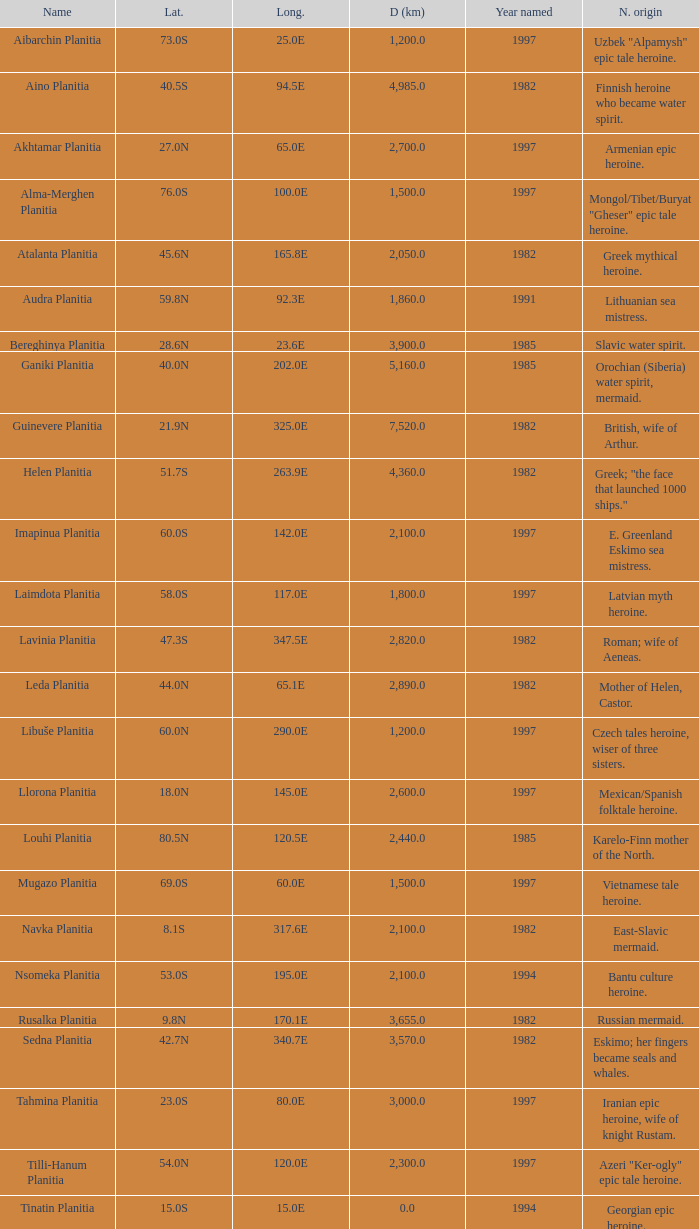What's the name origin of feature of diameter (km) 2,155.0 Karelo-Finn mermaid. 